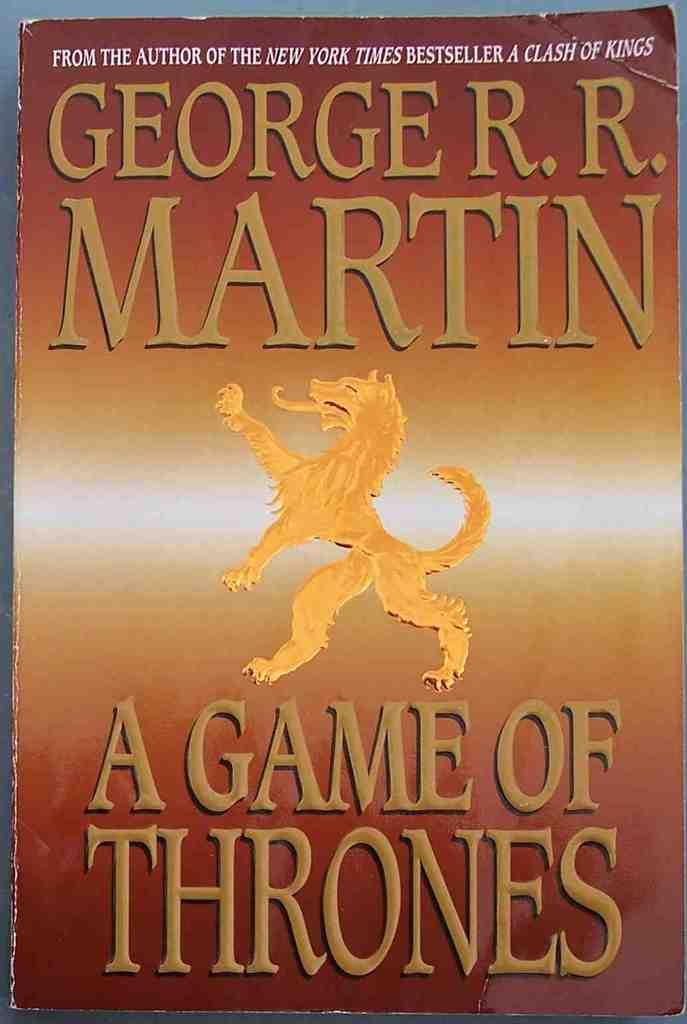<image>
Give a short and clear explanation of the subsequent image. Brown book called Game of Thrones lying on a table. 